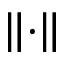<formula> <loc_0><loc_0><loc_500><loc_500>\left \| \cdot \right \|</formula> 